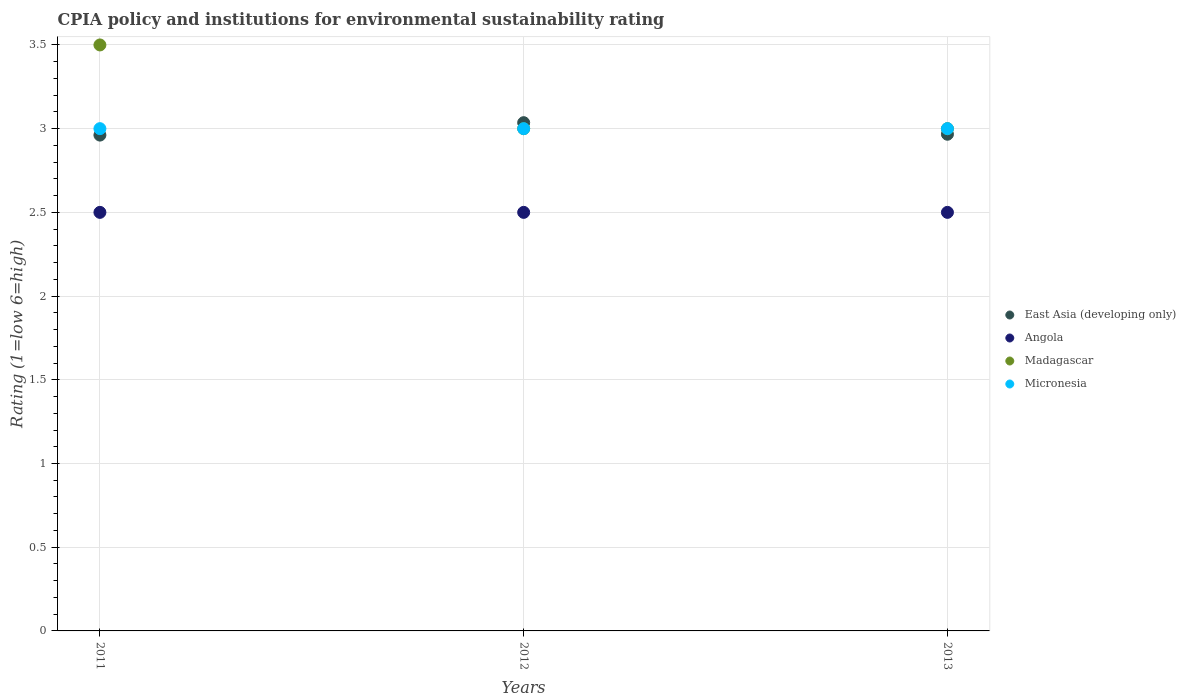How many different coloured dotlines are there?
Offer a very short reply. 4. Is the number of dotlines equal to the number of legend labels?
Keep it short and to the point. Yes. What is the CPIA rating in Micronesia in 2012?
Make the answer very short. 3. In which year was the CPIA rating in Angola minimum?
Provide a short and direct response. 2011. What is the difference between the CPIA rating in East Asia (developing only) in 2011 and that in 2013?
Your answer should be compact. -0.01. What is the difference between the CPIA rating in East Asia (developing only) in 2011 and the CPIA rating in Angola in 2012?
Ensure brevity in your answer.  0.46. What is the average CPIA rating in Madagascar per year?
Give a very brief answer. 3.17. In the year 2011, what is the difference between the CPIA rating in Madagascar and CPIA rating in East Asia (developing only)?
Your answer should be compact. 0.54. In how many years, is the CPIA rating in East Asia (developing only) greater than 2.3?
Your answer should be very brief. 3. What is the ratio of the CPIA rating in Madagascar in 2012 to that in 2013?
Keep it short and to the point. 1. Is the difference between the CPIA rating in Madagascar in 2012 and 2013 greater than the difference between the CPIA rating in East Asia (developing only) in 2012 and 2013?
Offer a terse response. No. What is the difference between the highest and the lowest CPIA rating in Madagascar?
Offer a terse response. 0.5. Is the sum of the CPIA rating in Madagascar in 2012 and 2013 greater than the maximum CPIA rating in Angola across all years?
Offer a very short reply. Yes. Does the CPIA rating in East Asia (developing only) monotonically increase over the years?
Provide a succinct answer. No. What is the difference between two consecutive major ticks on the Y-axis?
Your answer should be compact. 0.5. Are the values on the major ticks of Y-axis written in scientific E-notation?
Your response must be concise. No. How are the legend labels stacked?
Your answer should be very brief. Vertical. What is the title of the graph?
Ensure brevity in your answer.  CPIA policy and institutions for environmental sustainability rating. Does "Bolivia" appear as one of the legend labels in the graph?
Your answer should be compact. No. What is the label or title of the Y-axis?
Ensure brevity in your answer.  Rating (1=low 6=high). What is the Rating (1=low 6=high) of East Asia (developing only) in 2011?
Your answer should be very brief. 2.96. What is the Rating (1=low 6=high) in Angola in 2011?
Your answer should be compact. 2.5. What is the Rating (1=low 6=high) of Madagascar in 2011?
Ensure brevity in your answer.  3.5. What is the Rating (1=low 6=high) of East Asia (developing only) in 2012?
Make the answer very short. 3.04. What is the Rating (1=low 6=high) of Angola in 2012?
Give a very brief answer. 2.5. What is the Rating (1=low 6=high) of Madagascar in 2012?
Provide a succinct answer. 3. What is the Rating (1=low 6=high) of Micronesia in 2012?
Give a very brief answer. 3. What is the Rating (1=low 6=high) of East Asia (developing only) in 2013?
Your answer should be compact. 2.97. What is the Rating (1=low 6=high) of Angola in 2013?
Provide a short and direct response. 2.5. What is the Rating (1=low 6=high) of Madagascar in 2013?
Provide a succinct answer. 3. What is the Rating (1=low 6=high) of Micronesia in 2013?
Make the answer very short. 3. Across all years, what is the maximum Rating (1=low 6=high) of East Asia (developing only)?
Ensure brevity in your answer.  3.04. Across all years, what is the maximum Rating (1=low 6=high) of Angola?
Make the answer very short. 2.5. Across all years, what is the minimum Rating (1=low 6=high) of East Asia (developing only)?
Ensure brevity in your answer.  2.96. What is the total Rating (1=low 6=high) in East Asia (developing only) in the graph?
Your answer should be compact. 8.96. What is the total Rating (1=low 6=high) in Micronesia in the graph?
Your answer should be very brief. 9. What is the difference between the Rating (1=low 6=high) in East Asia (developing only) in 2011 and that in 2012?
Ensure brevity in your answer.  -0.07. What is the difference between the Rating (1=low 6=high) in Angola in 2011 and that in 2012?
Ensure brevity in your answer.  0. What is the difference between the Rating (1=low 6=high) in East Asia (developing only) in 2011 and that in 2013?
Offer a very short reply. -0.01. What is the difference between the Rating (1=low 6=high) in Angola in 2011 and that in 2013?
Ensure brevity in your answer.  0. What is the difference between the Rating (1=low 6=high) in Micronesia in 2011 and that in 2013?
Keep it short and to the point. 0. What is the difference between the Rating (1=low 6=high) of East Asia (developing only) in 2012 and that in 2013?
Ensure brevity in your answer.  0.07. What is the difference between the Rating (1=low 6=high) of Madagascar in 2012 and that in 2013?
Your answer should be very brief. 0. What is the difference between the Rating (1=low 6=high) of Micronesia in 2012 and that in 2013?
Ensure brevity in your answer.  0. What is the difference between the Rating (1=low 6=high) in East Asia (developing only) in 2011 and the Rating (1=low 6=high) in Angola in 2012?
Provide a succinct answer. 0.46. What is the difference between the Rating (1=low 6=high) in East Asia (developing only) in 2011 and the Rating (1=low 6=high) in Madagascar in 2012?
Give a very brief answer. -0.04. What is the difference between the Rating (1=low 6=high) in East Asia (developing only) in 2011 and the Rating (1=low 6=high) in Micronesia in 2012?
Offer a very short reply. -0.04. What is the difference between the Rating (1=low 6=high) of Angola in 2011 and the Rating (1=low 6=high) of Madagascar in 2012?
Ensure brevity in your answer.  -0.5. What is the difference between the Rating (1=low 6=high) of Angola in 2011 and the Rating (1=low 6=high) of Micronesia in 2012?
Keep it short and to the point. -0.5. What is the difference between the Rating (1=low 6=high) of East Asia (developing only) in 2011 and the Rating (1=low 6=high) of Angola in 2013?
Keep it short and to the point. 0.46. What is the difference between the Rating (1=low 6=high) in East Asia (developing only) in 2011 and the Rating (1=low 6=high) in Madagascar in 2013?
Provide a short and direct response. -0.04. What is the difference between the Rating (1=low 6=high) in East Asia (developing only) in 2011 and the Rating (1=low 6=high) in Micronesia in 2013?
Make the answer very short. -0.04. What is the difference between the Rating (1=low 6=high) in Angola in 2011 and the Rating (1=low 6=high) in Micronesia in 2013?
Your answer should be very brief. -0.5. What is the difference between the Rating (1=low 6=high) in East Asia (developing only) in 2012 and the Rating (1=low 6=high) in Angola in 2013?
Provide a succinct answer. 0.54. What is the difference between the Rating (1=low 6=high) in East Asia (developing only) in 2012 and the Rating (1=low 6=high) in Madagascar in 2013?
Ensure brevity in your answer.  0.04. What is the difference between the Rating (1=low 6=high) in East Asia (developing only) in 2012 and the Rating (1=low 6=high) in Micronesia in 2013?
Ensure brevity in your answer.  0.04. What is the difference between the Rating (1=low 6=high) of Angola in 2012 and the Rating (1=low 6=high) of Madagascar in 2013?
Your response must be concise. -0.5. What is the difference between the Rating (1=low 6=high) in Angola in 2012 and the Rating (1=low 6=high) in Micronesia in 2013?
Offer a terse response. -0.5. What is the difference between the Rating (1=low 6=high) in Madagascar in 2012 and the Rating (1=low 6=high) in Micronesia in 2013?
Provide a succinct answer. 0. What is the average Rating (1=low 6=high) of East Asia (developing only) per year?
Your response must be concise. 2.99. What is the average Rating (1=low 6=high) in Angola per year?
Keep it short and to the point. 2.5. What is the average Rating (1=low 6=high) of Madagascar per year?
Your response must be concise. 3.17. What is the average Rating (1=low 6=high) of Micronesia per year?
Your answer should be compact. 3. In the year 2011, what is the difference between the Rating (1=low 6=high) in East Asia (developing only) and Rating (1=low 6=high) in Angola?
Your answer should be very brief. 0.46. In the year 2011, what is the difference between the Rating (1=low 6=high) of East Asia (developing only) and Rating (1=low 6=high) of Madagascar?
Provide a short and direct response. -0.54. In the year 2011, what is the difference between the Rating (1=low 6=high) of East Asia (developing only) and Rating (1=low 6=high) of Micronesia?
Offer a terse response. -0.04. In the year 2011, what is the difference between the Rating (1=low 6=high) in Angola and Rating (1=low 6=high) in Micronesia?
Give a very brief answer. -0.5. In the year 2012, what is the difference between the Rating (1=low 6=high) of East Asia (developing only) and Rating (1=low 6=high) of Angola?
Make the answer very short. 0.54. In the year 2012, what is the difference between the Rating (1=low 6=high) in East Asia (developing only) and Rating (1=low 6=high) in Madagascar?
Make the answer very short. 0.04. In the year 2012, what is the difference between the Rating (1=low 6=high) in East Asia (developing only) and Rating (1=low 6=high) in Micronesia?
Ensure brevity in your answer.  0.04. In the year 2012, what is the difference between the Rating (1=low 6=high) in Angola and Rating (1=low 6=high) in Micronesia?
Provide a short and direct response. -0.5. In the year 2013, what is the difference between the Rating (1=low 6=high) of East Asia (developing only) and Rating (1=low 6=high) of Angola?
Provide a short and direct response. 0.47. In the year 2013, what is the difference between the Rating (1=low 6=high) in East Asia (developing only) and Rating (1=low 6=high) in Madagascar?
Offer a very short reply. -0.03. In the year 2013, what is the difference between the Rating (1=low 6=high) of East Asia (developing only) and Rating (1=low 6=high) of Micronesia?
Keep it short and to the point. -0.03. What is the ratio of the Rating (1=low 6=high) of East Asia (developing only) in 2011 to that in 2012?
Make the answer very short. 0.98. What is the ratio of the Rating (1=low 6=high) of Micronesia in 2011 to that in 2012?
Your response must be concise. 1. What is the ratio of the Rating (1=low 6=high) in East Asia (developing only) in 2011 to that in 2013?
Ensure brevity in your answer.  1. What is the ratio of the Rating (1=low 6=high) of Micronesia in 2011 to that in 2013?
Keep it short and to the point. 1. What is the ratio of the Rating (1=low 6=high) of East Asia (developing only) in 2012 to that in 2013?
Give a very brief answer. 1.02. What is the ratio of the Rating (1=low 6=high) in Angola in 2012 to that in 2013?
Your response must be concise. 1. What is the ratio of the Rating (1=low 6=high) of Madagascar in 2012 to that in 2013?
Provide a short and direct response. 1. What is the ratio of the Rating (1=low 6=high) in Micronesia in 2012 to that in 2013?
Your response must be concise. 1. What is the difference between the highest and the second highest Rating (1=low 6=high) in East Asia (developing only)?
Your answer should be very brief. 0.07. What is the difference between the highest and the second highest Rating (1=low 6=high) of Madagascar?
Offer a very short reply. 0.5. What is the difference between the highest and the lowest Rating (1=low 6=high) in East Asia (developing only)?
Provide a short and direct response. 0.07. What is the difference between the highest and the lowest Rating (1=low 6=high) in Angola?
Ensure brevity in your answer.  0. What is the difference between the highest and the lowest Rating (1=low 6=high) in Madagascar?
Your answer should be very brief. 0.5. What is the difference between the highest and the lowest Rating (1=low 6=high) in Micronesia?
Your answer should be compact. 0. 